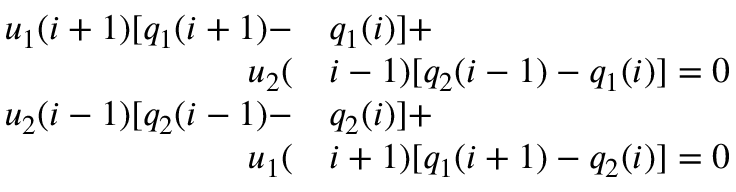Convert formula to latex. <formula><loc_0><loc_0><loc_500><loc_500>\begin{array} { r l } { u _ { 1 } ( i + 1 ) [ q _ { 1 } ( i + 1 ) - } & q _ { 1 } ( i ) ] + } \\ { u _ { 2 } ( } & i - 1 ) [ q _ { 2 } ( i - 1 ) - q _ { 1 } ( i ) ] = 0 } \\ { u _ { 2 } ( i - 1 ) [ q _ { 2 } ( i - 1 ) - } & q _ { 2 } ( i ) ] + } \\ { u _ { 1 } ( } & i + 1 ) [ q _ { 1 } ( i + 1 ) - q _ { 2 } ( i ) ] = 0 } \end{array}</formula> 